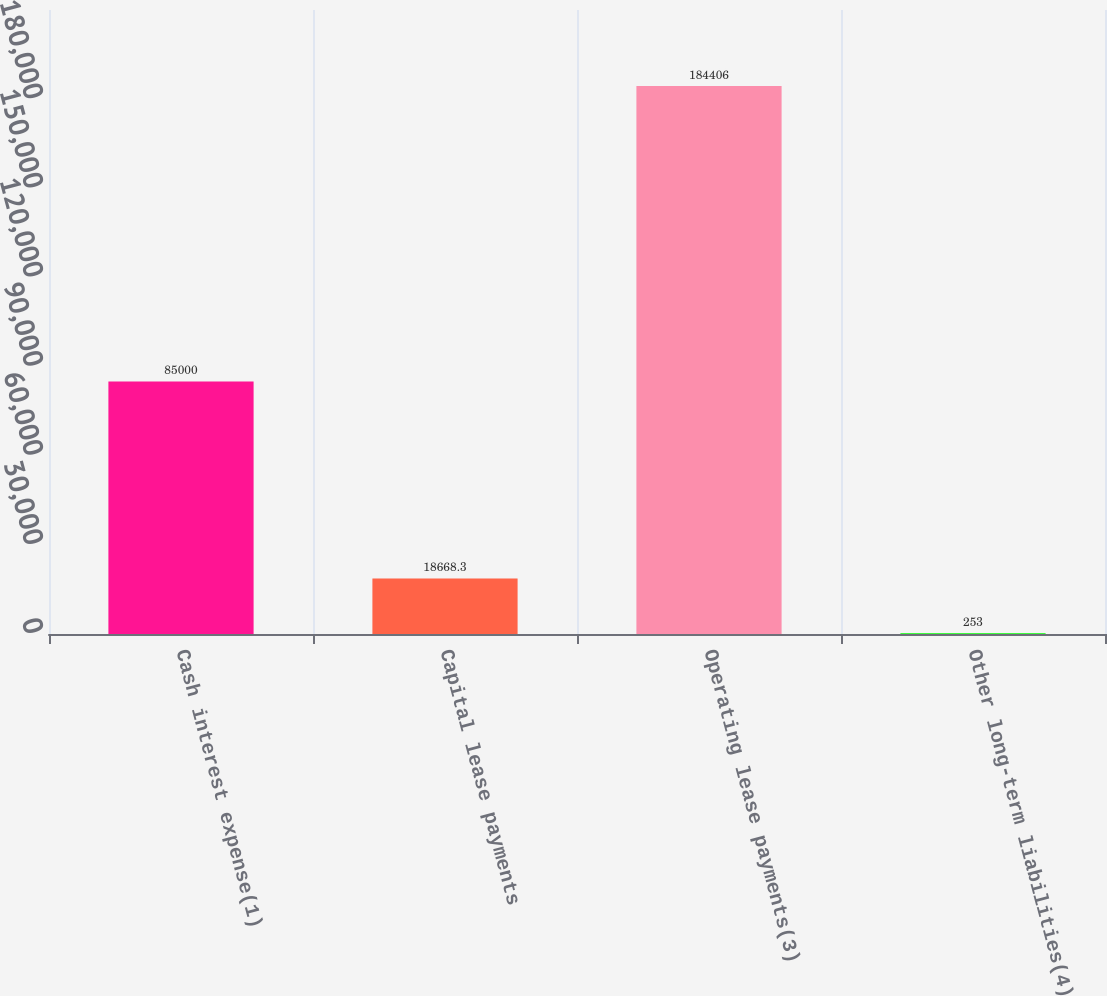Convert chart. <chart><loc_0><loc_0><loc_500><loc_500><bar_chart><fcel>Cash interest expense(1)<fcel>Capital lease payments<fcel>Operating lease payments(3)<fcel>Other long-term liabilities(4)<nl><fcel>85000<fcel>18668.3<fcel>184406<fcel>253<nl></chart> 